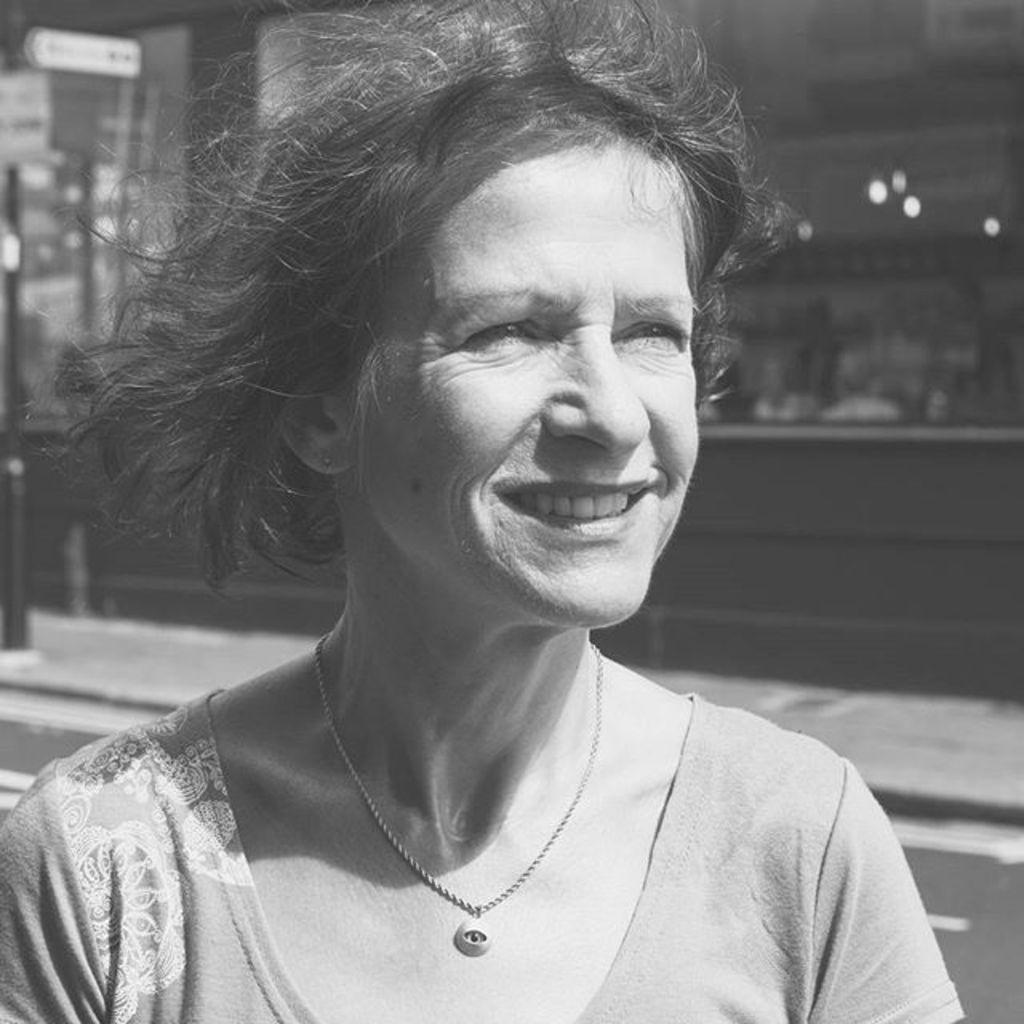Who is present in the image? There is a woman in the image. What is the woman wearing around her neck? The woman is wearing a necklace. What type of clothing is the woman wearing on her upper body? The woman is wearing a top. What expression does the woman have on her face? The woman is smiling. What is the color scheme of the image? The image is black and white in color. What type of cushion is the woman sitting on in the image? There is no cushion present in the image, as it is a black and white photograph of a woman. How many light sources are visible in the image? There are no light sources visible in the image, as it is a black and white photograph of a woman. 